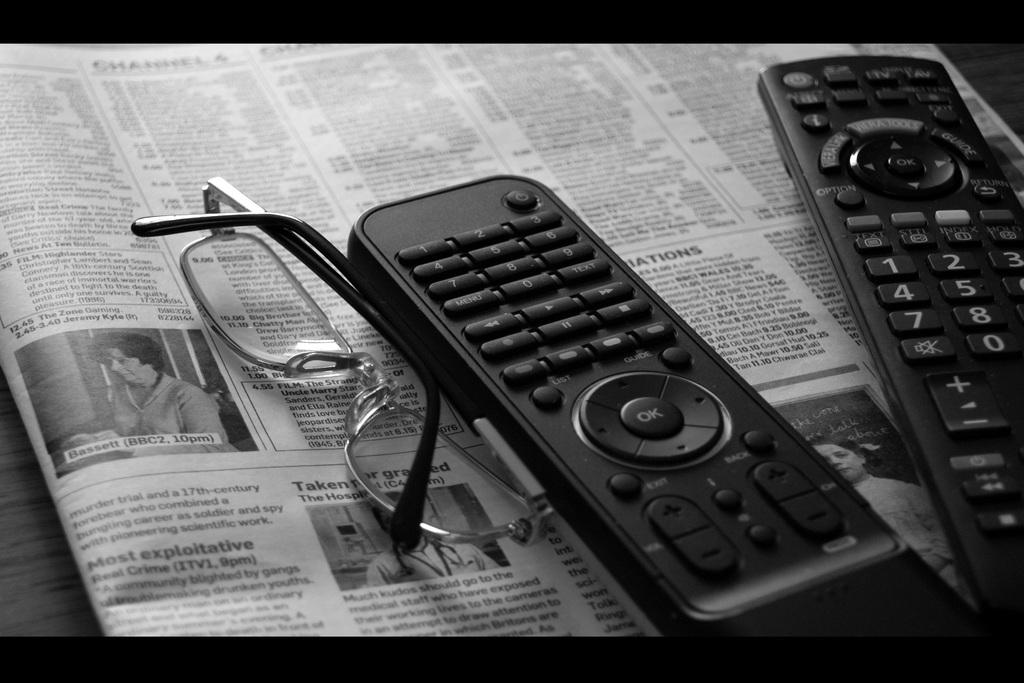What type of electronic devices can be seen in the image? There are remotes in the image. What type of accessory is present in the image? There are spectacles in the image. What type of reading material is present in the image? There is a newspaper in the image. Where are these objects located in the image? All of these objects are on a platform. What committee is responsible for organizing the items on the shelf in the image? There is no committee mentioned in the image, and the objects are on a platform, not a shelf. 